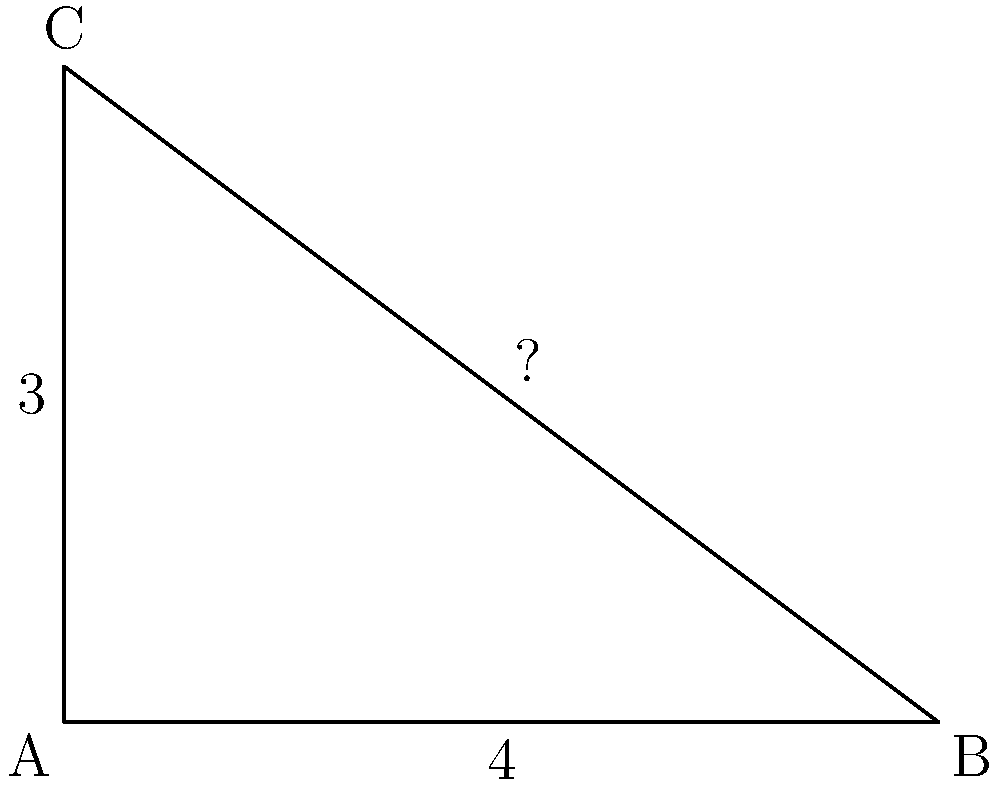In the right triangle ABC shown above, the length of side AC is 3 units and the length of side AB is 4 units. What is the length of the hypotenuse BC? To find the length of the hypotenuse in a right triangle, we can use the Pythagorean theorem. This theorem states that in a right triangle, the square of the length of the hypotenuse is equal to the sum of the squares of the lengths of the other two sides.

Let's follow these steps:

1. Identify the known sides:
   - Side AC (opposite) = 3 units
   - Side AB (adjacent) = 4 units
   - Side BC (hypotenuse) = unknown (let's call it x)

2. Write the Pythagorean theorem:
   $a^2 + b^2 = c^2$, where c is the hypotenuse

3. Plug in the known values:
   $3^2 + 4^2 = x^2$

4. Simplify:
   $9 + 16 = x^2$
   $25 = x^2$

5. Solve for x by taking the square root of both sides:
   $x = \sqrt{25} = 5$

Therefore, the length of the hypotenuse BC is 5 units.
Answer: 5 units 